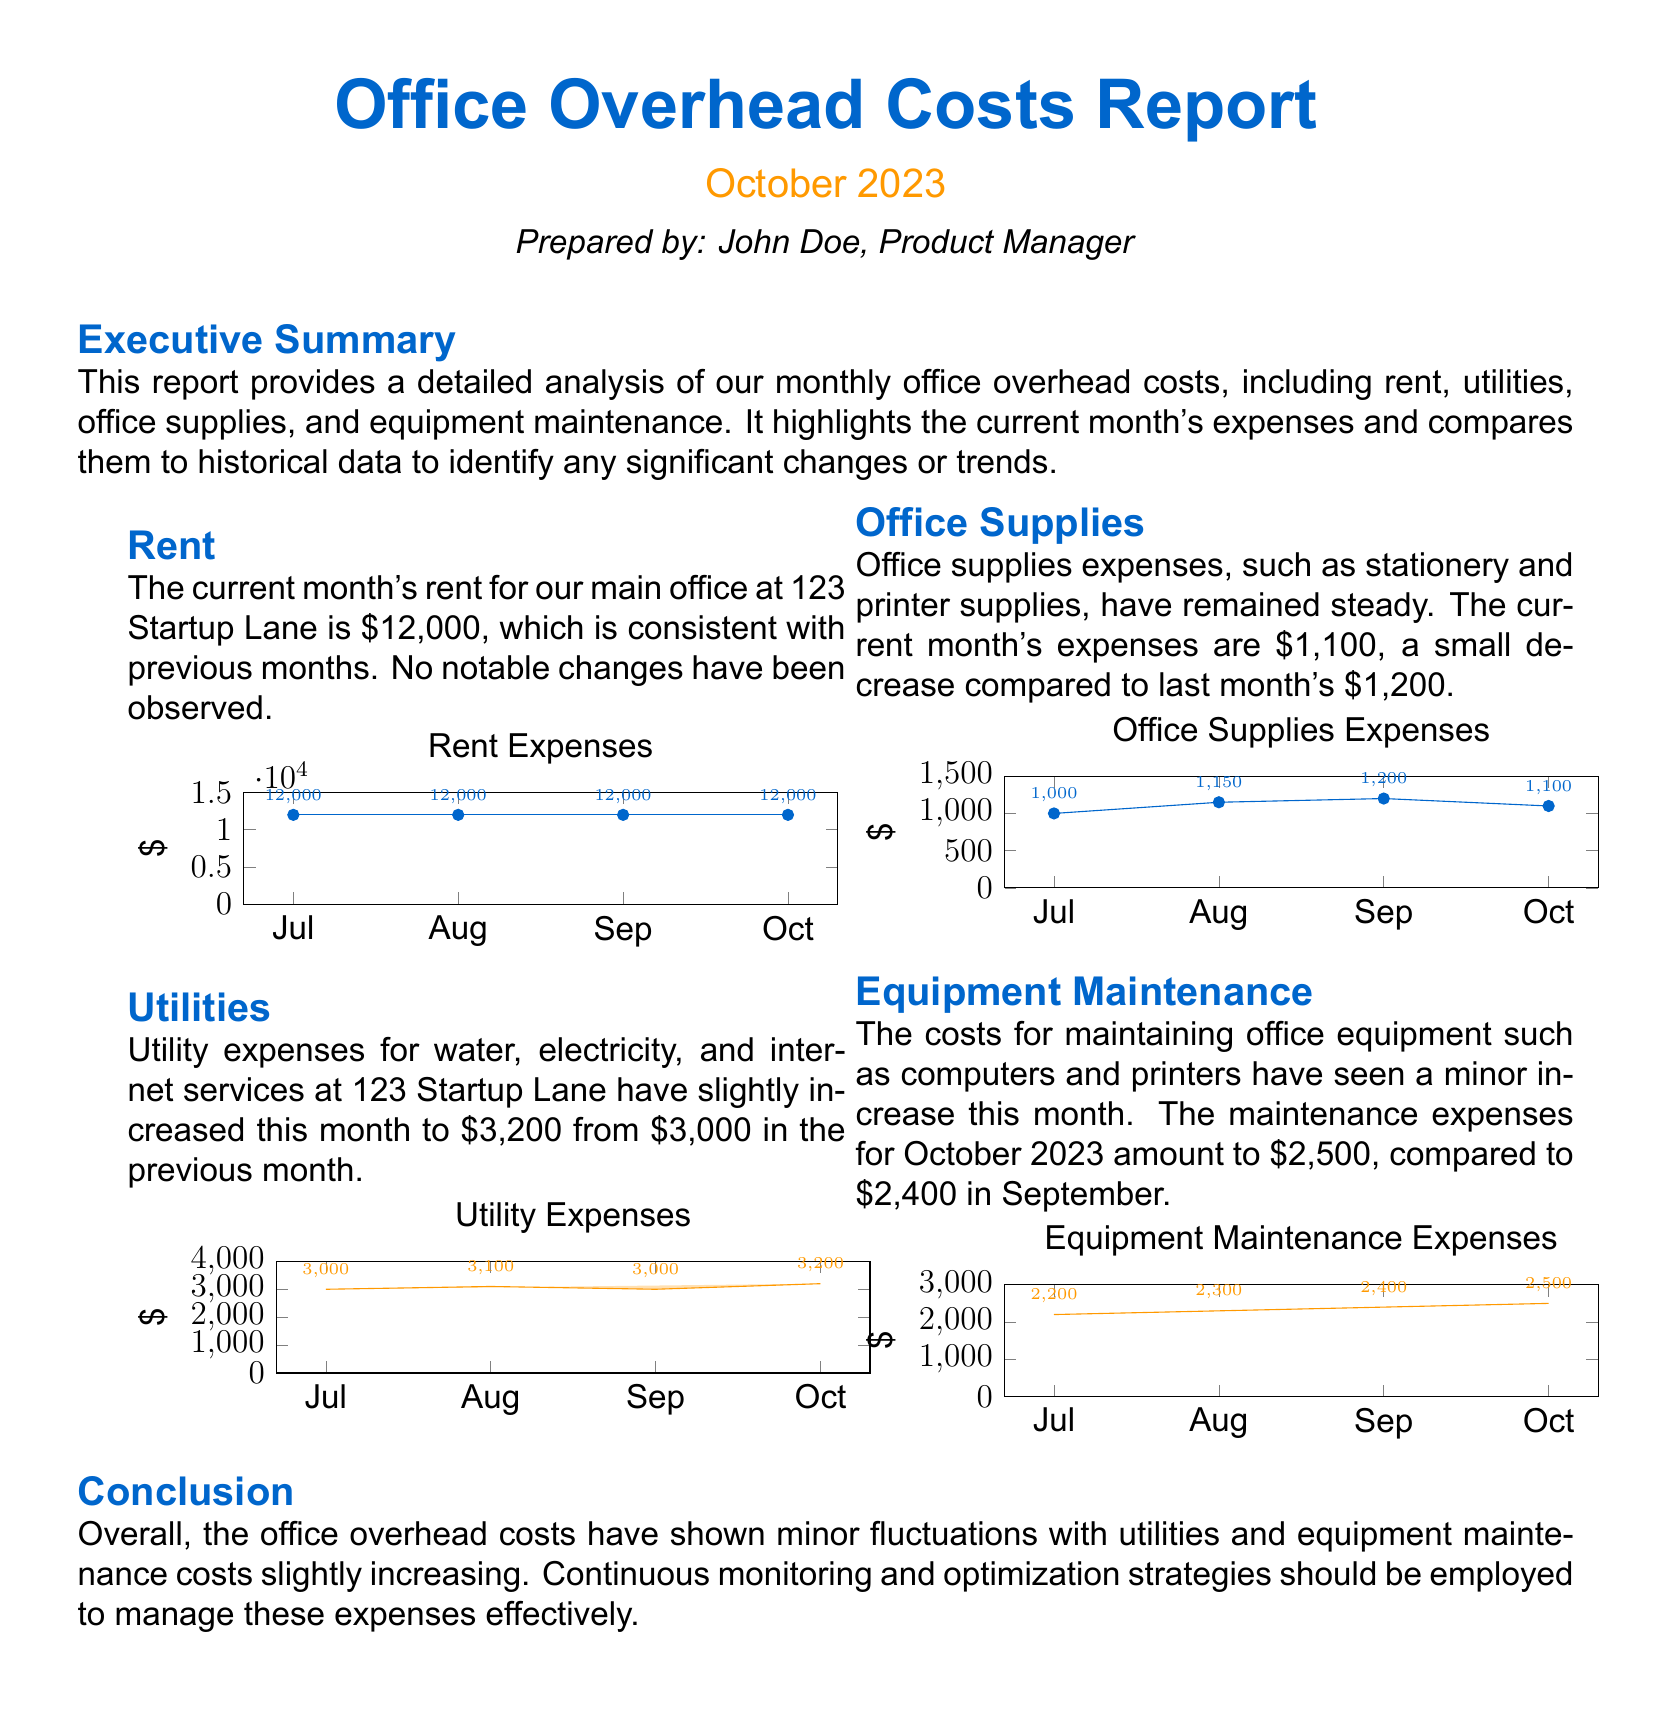What is the rent for October 2023? The document states that the rent for October 2023 is $12,000, which is consistent with previous months.
Answer: $12,000 What were the utility expenses in September? The report mentioned that utility expenses in September were $3,000 before increasing to $3,200 in October.
Answer: $3,000 How much did office supplies cost in October? The document states that office supplies expenses for October amounted to $1,100, which is a decrease compared to last month.
Answer: $1,100 What was the change in equipment maintenance costs from September to October? The report indicates that equipment maintenance expenses increased from $2,400 in September to $2,500 in October.
Answer: $100 What was the total cost of utilities in October? The document indicates that the total cost of utilities in October was $3,200, reflecting a slight increase from previous months.
Answer: $3,200 Which category had the largest expense for October? The comparison in expenses shows that rent was the largest expense for October 2023 at $12,000.
Answer: Rent What is the percentage increase in utility expenses from August to October? The report shows an increase from $3,100 in August to $3,200 in October, which is a percentage increase of approximately 3.23%.
Answer: 3.23% Did office supplies costs increase or decrease in October? The document states that office supplies costs decreased from $1,200 in September to $1,100 in October.
Answer: Decrease What are the two colors used in the report for visualizations? The report uses maincolor for rent and office supplies expenses, and secondcolor for utilities and equipment maintenance expenses.
Answer: Maincolor and secondcolor 